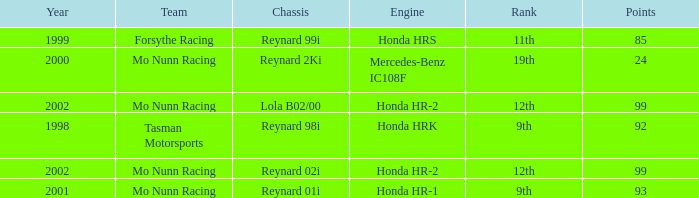What is the total number of points of the honda hr-1 engine? 1.0. 